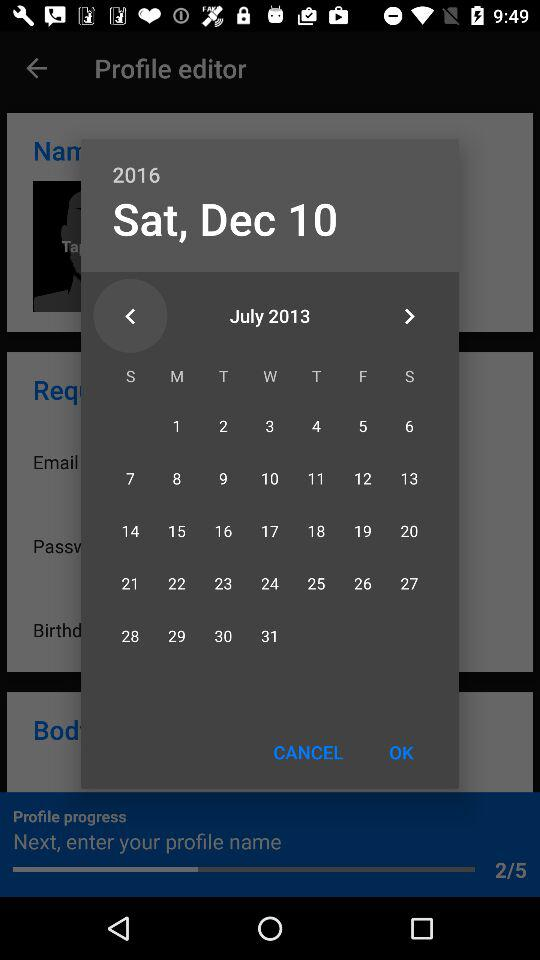At what step of the profile progress am I? You are at the 2nd step of the profile progress. 